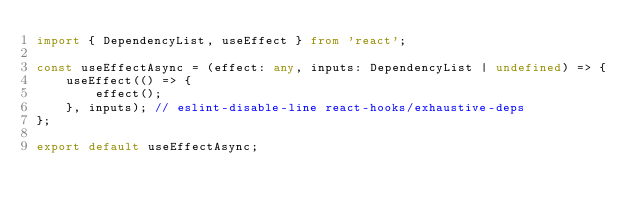<code> <loc_0><loc_0><loc_500><loc_500><_TypeScript_>import { DependencyList, useEffect } from 'react';

const useEffectAsync = (effect: any, inputs: DependencyList | undefined) => {
	useEffect(() => {
		effect();
	}, inputs); // eslint-disable-line react-hooks/exhaustive-deps
};

export default useEffectAsync;
</code> 